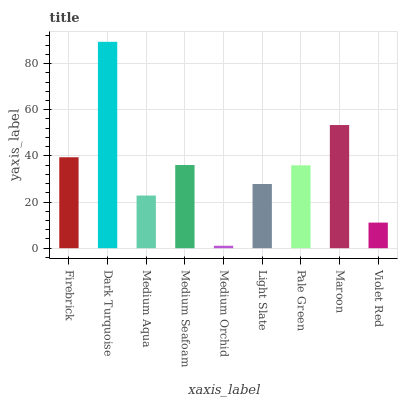Is Medium Aqua the minimum?
Answer yes or no. No. Is Medium Aqua the maximum?
Answer yes or no. No. Is Dark Turquoise greater than Medium Aqua?
Answer yes or no. Yes. Is Medium Aqua less than Dark Turquoise?
Answer yes or no. Yes. Is Medium Aqua greater than Dark Turquoise?
Answer yes or no. No. Is Dark Turquoise less than Medium Aqua?
Answer yes or no. No. Is Pale Green the high median?
Answer yes or no. Yes. Is Pale Green the low median?
Answer yes or no. Yes. Is Dark Turquoise the high median?
Answer yes or no. No. Is Firebrick the low median?
Answer yes or no. No. 